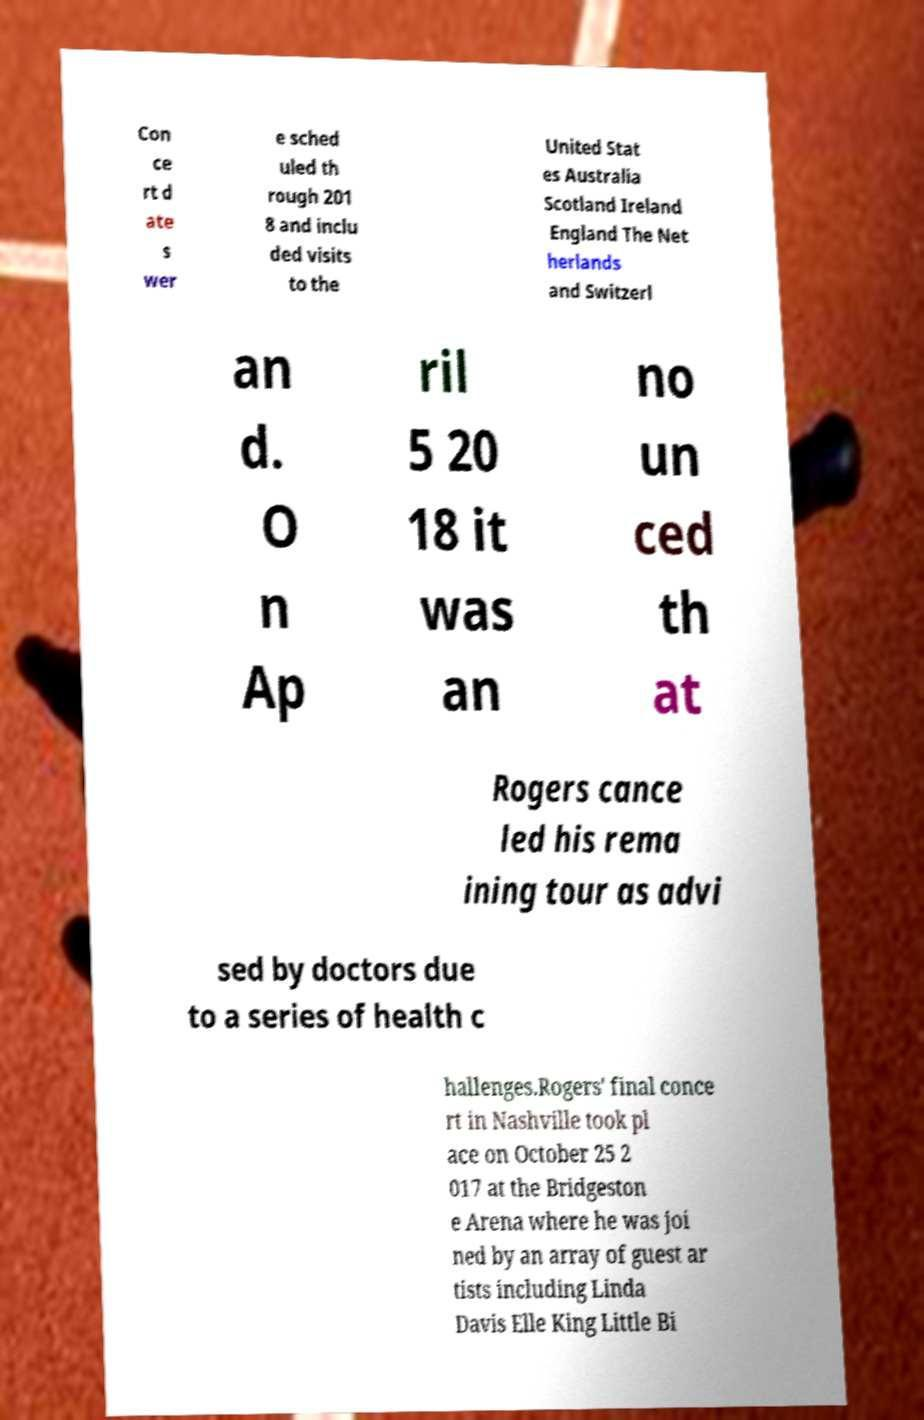Can you accurately transcribe the text from the provided image for me? Con ce rt d ate s wer e sched uled th rough 201 8 and inclu ded visits to the United Stat es Australia Scotland Ireland England The Net herlands and Switzerl an d. O n Ap ril 5 20 18 it was an no un ced th at Rogers cance led his rema ining tour as advi sed by doctors due to a series of health c hallenges.Rogers' final conce rt in Nashville took pl ace on October 25 2 017 at the Bridgeston e Arena where he was joi ned by an array of guest ar tists including Linda Davis Elle King Little Bi 